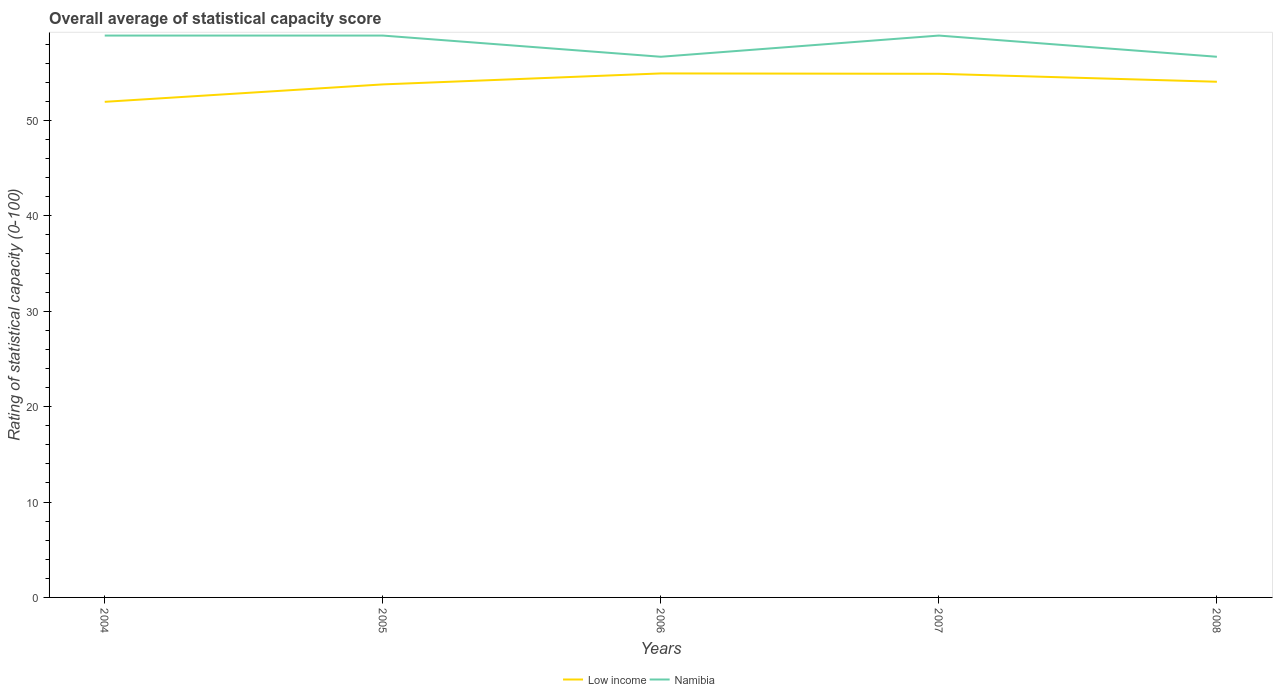How many different coloured lines are there?
Offer a very short reply. 2. Does the line corresponding to Namibia intersect with the line corresponding to Low income?
Your response must be concise. No. Across all years, what is the maximum rating of statistical capacity in Namibia?
Provide a succinct answer. 56.67. In which year was the rating of statistical capacity in Low income maximum?
Your answer should be compact. 2004. What is the total rating of statistical capacity in Namibia in the graph?
Offer a terse response. -2.22. What is the difference between the highest and the second highest rating of statistical capacity in Low income?
Provide a succinct answer. 2.98. What is the difference between the highest and the lowest rating of statistical capacity in Namibia?
Ensure brevity in your answer.  3. Is the rating of statistical capacity in Namibia strictly greater than the rating of statistical capacity in Low income over the years?
Keep it short and to the point. No. How many years are there in the graph?
Your response must be concise. 5. Does the graph contain any zero values?
Keep it short and to the point. No. Where does the legend appear in the graph?
Ensure brevity in your answer.  Bottom center. What is the title of the graph?
Offer a terse response. Overall average of statistical capacity score. What is the label or title of the Y-axis?
Ensure brevity in your answer.  Rating of statistical capacity (0-100). What is the Rating of statistical capacity (0-100) in Low income in 2004?
Give a very brief answer. 51.94. What is the Rating of statistical capacity (0-100) in Namibia in 2004?
Give a very brief answer. 58.89. What is the Rating of statistical capacity (0-100) of Low income in 2005?
Your answer should be very brief. 53.77. What is the Rating of statistical capacity (0-100) in Namibia in 2005?
Ensure brevity in your answer.  58.89. What is the Rating of statistical capacity (0-100) in Low income in 2006?
Make the answer very short. 54.92. What is the Rating of statistical capacity (0-100) in Namibia in 2006?
Offer a very short reply. 56.67. What is the Rating of statistical capacity (0-100) of Low income in 2007?
Ensure brevity in your answer.  54.88. What is the Rating of statistical capacity (0-100) in Namibia in 2007?
Offer a terse response. 58.89. What is the Rating of statistical capacity (0-100) of Low income in 2008?
Provide a short and direct response. 54.05. What is the Rating of statistical capacity (0-100) of Namibia in 2008?
Keep it short and to the point. 56.67. Across all years, what is the maximum Rating of statistical capacity (0-100) in Low income?
Ensure brevity in your answer.  54.92. Across all years, what is the maximum Rating of statistical capacity (0-100) of Namibia?
Your response must be concise. 58.89. Across all years, what is the minimum Rating of statistical capacity (0-100) in Low income?
Your answer should be compact. 51.94. Across all years, what is the minimum Rating of statistical capacity (0-100) in Namibia?
Offer a very short reply. 56.67. What is the total Rating of statistical capacity (0-100) in Low income in the graph?
Keep it short and to the point. 269.56. What is the total Rating of statistical capacity (0-100) in Namibia in the graph?
Give a very brief answer. 290. What is the difference between the Rating of statistical capacity (0-100) of Low income in 2004 and that in 2005?
Your response must be concise. -1.83. What is the difference between the Rating of statistical capacity (0-100) in Namibia in 2004 and that in 2005?
Keep it short and to the point. 0. What is the difference between the Rating of statistical capacity (0-100) in Low income in 2004 and that in 2006?
Keep it short and to the point. -2.98. What is the difference between the Rating of statistical capacity (0-100) of Namibia in 2004 and that in 2006?
Provide a succinct answer. 2.22. What is the difference between the Rating of statistical capacity (0-100) of Low income in 2004 and that in 2007?
Ensure brevity in your answer.  -2.94. What is the difference between the Rating of statistical capacity (0-100) in Namibia in 2004 and that in 2007?
Your response must be concise. 0. What is the difference between the Rating of statistical capacity (0-100) of Low income in 2004 and that in 2008?
Offer a terse response. -2.1. What is the difference between the Rating of statistical capacity (0-100) of Namibia in 2004 and that in 2008?
Provide a short and direct response. 2.22. What is the difference between the Rating of statistical capacity (0-100) in Low income in 2005 and that in 2006?
Provide a short and direct response. -1.15. What is the difference between the Rating of statistical capacity (0-100) in Namibia in 2005 and that in 2006?
Your answer should be compact. 2.22. What is the difference between the Rating of statistical capacity (0-100) of Low income in 2005 and that in 2007?
Provide a short and direct response. -1.11. What is the difference between the Rating of statistical capacity (0-100) in Namibia in 2005 and that in 2007?
Offer a terse response. 0. What is the difference between the Rating of statistical capacity (0-100) of Low income in 2005 and that in 2008?
Give a very brief answer. -0.28. What is the difference between the Rating of statistical capacity (0-100) of Namibia in 2005 and that in 2008?
Your answer should be compact. 2.22. What is the difference between the Rating of statistical capacity (0-100) in Low income in 2006 and that in 2007?
Offer a terse response. 0.04. What is the difference between the Rating of statistical capacity (0-100) of Namibia in 2006 and that in 2007?
Offer a terse response. -2.22. What is the difference between the Rating of statistical capacity (0-100) in Low income in 2006 and that in 2008?
Your response must be concise. 0.87. What is the difference between the Rating of statistical capacity (0-100) in Namibia in 2006 and that in 2008?
Make the answer very short. 0. What is the difference between the Rating of statistical capacity (0-100) in Low income in 2007 and that in 2008?
Your answer should be very brief. 0.83. What is the difference between the Rating of statistical capacity (0-100) of Namibia in 2007 and that in 2008?
Your answer should be very brief. 2.22. What is the difference between the Rating of statistical capacity (0-100) of Low income in 2004 and the Rating of statistical capacity (0-100) of Namibia in 2005?
Offer a terse response. -6.94. What is the difference between the Rating of statistical capacity (0-100) of Low income in 2004 and the Rating of statistical capacity (0-100) of Namibia in 2006?
Offer a terse response. -4.72. What is the difference between the Rating of statistical capacity (0-100) of Low income in 2004 and the Rating of statistical capacity (0-100) of Namibia in 2007?
Offer a terse response. -6.94. What is the difference between the Rating of statistical capacity (0-100) of Low income in 2004 and the Rating of statistical capacity (0-100) of Namibia in 2008?
Ensure brevity in your answer.  -4.72. What is the difference between the Rating of statistical capacity (0-100) in Low income in 2005 and the Rating of statistical capacity (0-100) in Namibia in 2006?
Your answer should be compact. -2.9. What is the difference between the Rating of statistical capacity (0-100) in Low income in 2005 and the Rating of statistical capacity (0-100) in Namibia in 2007?
Give a very brief answer. -5.12. What is the difference between the Rating of statistical capacity (0-100) of Low income in 2005 and the Rating of statistical capacity (0-100) of Namibia in 2008?
Provide a short and direct response. -2.9. What is the difference between the Rating of statistical capacity (0-100) of Low income in 2006 and the Rating of statistical capacity (0-100) of Namibia in 2007?
Give a very brief answer. -3.97. What is the difference between the Rating of statistical capacity (0-100) of Low income in 2006 and the Rating of statistical capacity (0-100) of Namibia in 2008?
Ensure brevity in your answer.  -1.75. What is the difference between the Rating of statistical capacity (0-100) in Low income in 2007 and the Rating of statistical capacity (0-100) in Namibia in 2008?
Your answer should be very brief. -1.79. What is the average Rating of statistical capacity (0-100) in Low income per year?
Offer a terse response. 53.91. In the year 2004, what is the difference between the Rating of statistical capacity (0-100) of Low income and Rating of statistical capacity (0-100) of Namibia?
Your answer should be very brief. -6.94. In the year 2005, what is the difference between the Rating of statistical capacity (0-100) of Low income and Rating of statistical capacity (0-100) of Namibia?
Make the answer very short. -5.12. In the year 2006, what is the difference between the Rating of statistical capacity (0-100) of Low income and Rating of statistical capacity (0-100) of Namibia?
Ensure brevity in your answer.  -1.75. In the year 2007, what is the difference between the Rating of statistical capacity (0-100) in Low income and Rating of statistical capacity (0-100) in Namibia?
Offer a terse response. -4.01. In the year 2008, what is the difference between the Rating of statistical capacity (0-100) in Low income and Rating of statistical capacity (0-100) in Namibia?
Your response must be concise. -2.62. What is the ratio of the Rating of statistical capacity (0-100) of Low income in 2004 to that in 2005?
Offer a very short reply. 0.97. What is the ratio of the Rating of statistical capacity (0-100) of Low income in 2004 to that in 2006?
Give a very brief answer. 0.95. What is the ratio of the Rating of statistical capacity (0-100) in Namibia in 2004 to that in 2006?
Give a very brief answer. 1.04. What is the ratio of the Rating of statistical capacity (0-100) in Low income in 2004 to that in 2007?
Provide a succinct answer. 0.95. What is the ratio of the Rating of statistical capacity (0-100) in Namibia in 2004 to that in 2007?
Your answer should be compact. 1. What is the ratio of the Rating of statistical capacity (0-100) in Low income in 2004 to that in 2008?
Your answer should be compact. 0.96. What is the ratio of the Rating of statistical capacity (0-100) in Namibia in 2004 to that in 2008?
Provide a succinct answer. 1.04. What is the ratio of the Rating of statistical capacity (0-100) in Low income in 2005 to that in 2006?
Give a very brief answer. 0.98. What is the ratio of the Rating of statistical capacity (0-100) in Namibia in 2005 to that in 2006?
Offer a very short reply. 1.04. What is the ratio of the Rating of statistical capacity (0-100) in Low income in 2005 to that in 2007?
Give a very brief answer. 0.98. What is the ratio of the Rating of statistical capacity (0-100) in Low income in 2005 to that in 2008?
Your response must be concise. 0.99. What is the ratio of the Rating of statistical capacity (0-100) of Namibia in 2005 to that in 2008?
Give a very brief answer. 1.04. What is the ratio of the Rating of statistical capacity (0-100) of Namibia in 2006 to that in 2007?
Offer a very short reply. 0.96. What is the ratio of the Rating of statistical capacity (0-100) in Low income in 2006 to that in 2008?
Make the answer very short. 1.02. What is the ratio of the Rating of statistical capacity (0-100) in Low income in 2007 to that in 2008?
Offer a very short reply. 1.02. What is the ratio of the Rating of statistical capacity (0-100) in Namibia in 2007 to that in 2008?
Provide a succinct answer. 1.04. What is the difference between the highest and the second highest Rating of statistical capacity (0-100) in Low income?
Give a very brief answer. 0.04. What is the difference between the highest and the lowest Rating of statistical capacity (0-100) of Low income?
Your answer should be compact. 2.98. What is the difference between the highest and the lowest Rating of statistical capacity (0-100) of Namibia?
Your answer should be very brief. 2.22. 